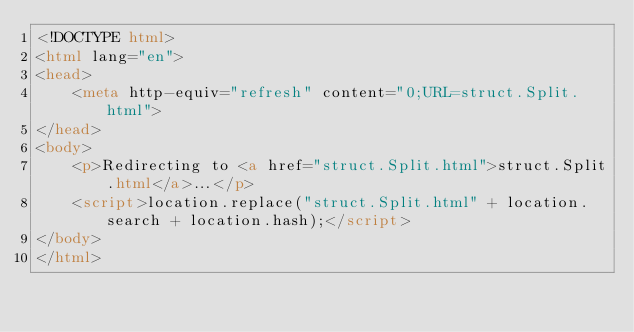<code> <loc_0><loc_0><loc_500><loc_500><_HTML_><!DOCTYPE html>
<html lang="en">
<head>
    <meta http-equiv="refresh" content="0;URL=struct.Split.html">
</head>
<body>
    <p>Redirecting to <a href="struct.Split.html">struct.Split.html</a>...</p>
    <script>location.replace("struct.Split.html" + location.search + location.hash);</script>
</body>
</html></code> 